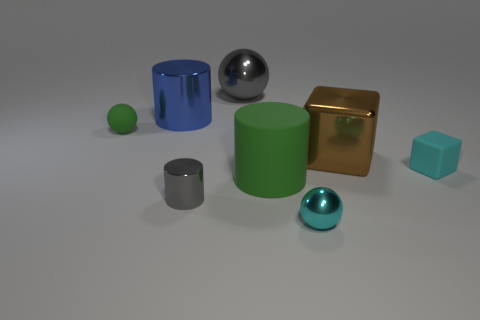Subtract 1 balls. How many balls are left? 2 Subtract all big cylinders. How many cylinders are left? 1 Add 1 big matte objects. How many objects exist? 9 Subtract all cylinders. How many objects are left? 5 Add 7 cyan cubes. How many cyan cubes exist? 8 Subtract 0 red balls. How many objects are left? 8 Subtract all tiny cubes. Subtract all large gray blocks. How many objects are left? 7 Add 1 cyan matte things. How many cyan matte things are left? 2 